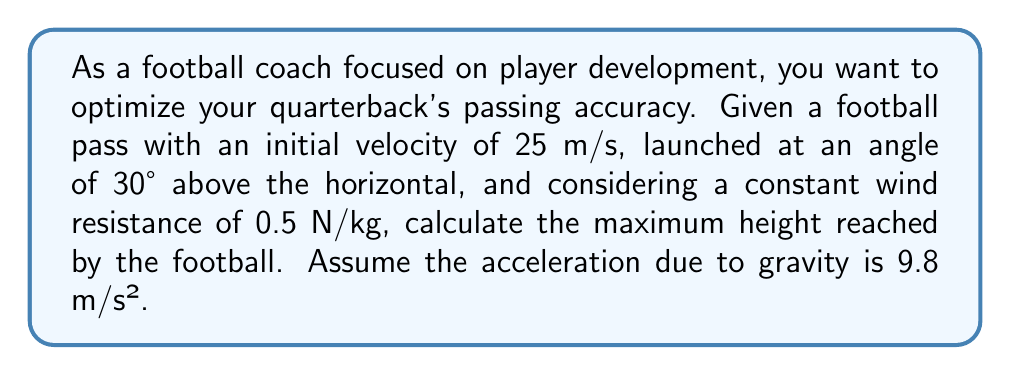Teach me how to tackle this problem. To solve this problem, we need to consider the equations of motion for a projectile with air resistance. Let's break it down step-by-step:

1. Resolve the initial velocity into horizontal and vertical components:
   $v_{0x} = v_0 \cos \theta = 25 \cos 30° = 21.65$ m/s
   $v_{0y} = v_0 \sin \theta = 25 \sin 30° = 12.5$ m/s

2. The force of air resistance is given as 0.5 N/kg, which is equivalent to an acceleration of 0.5 m/s² opposing the motion. We'll assume this is constant for simplification.

3. In the vertical direction, we have:
   Acceleration due to gravity: $a_y = -g = -9.8$ m/s²
   Acceleration due to air resistance: $a_r = -0.5$ m/s²
   Total vertical acceleration: $a_{total} = -10.3$ m/s²

4. The time to reach maximum height is when the vertical velocity becomes zero:
   $$v_y = v_{0y} + a_{total}t = 0$$
   $$12.5 - 10.3t = 0$$
   $$t = \frac{12.5}{10.3} = 1.21 \text{ seconds}$$

5. Now we can calculate the maximum height using the equation:
   $$y = v_{0y}t + \frac{1}{2}a_{total}t^2$$
   $$y = 12.5(1.21) + \frac{1}{2}(-10.3)(1.21)^2$$
   $$y = 15.13 - 7.55 = 7.58 \text{ meters}$$

Thus, the football reaches a maximum height of approximately 7.58 meters.
Answer: The maximum height reached by the football is approximately 7.58 meters. 